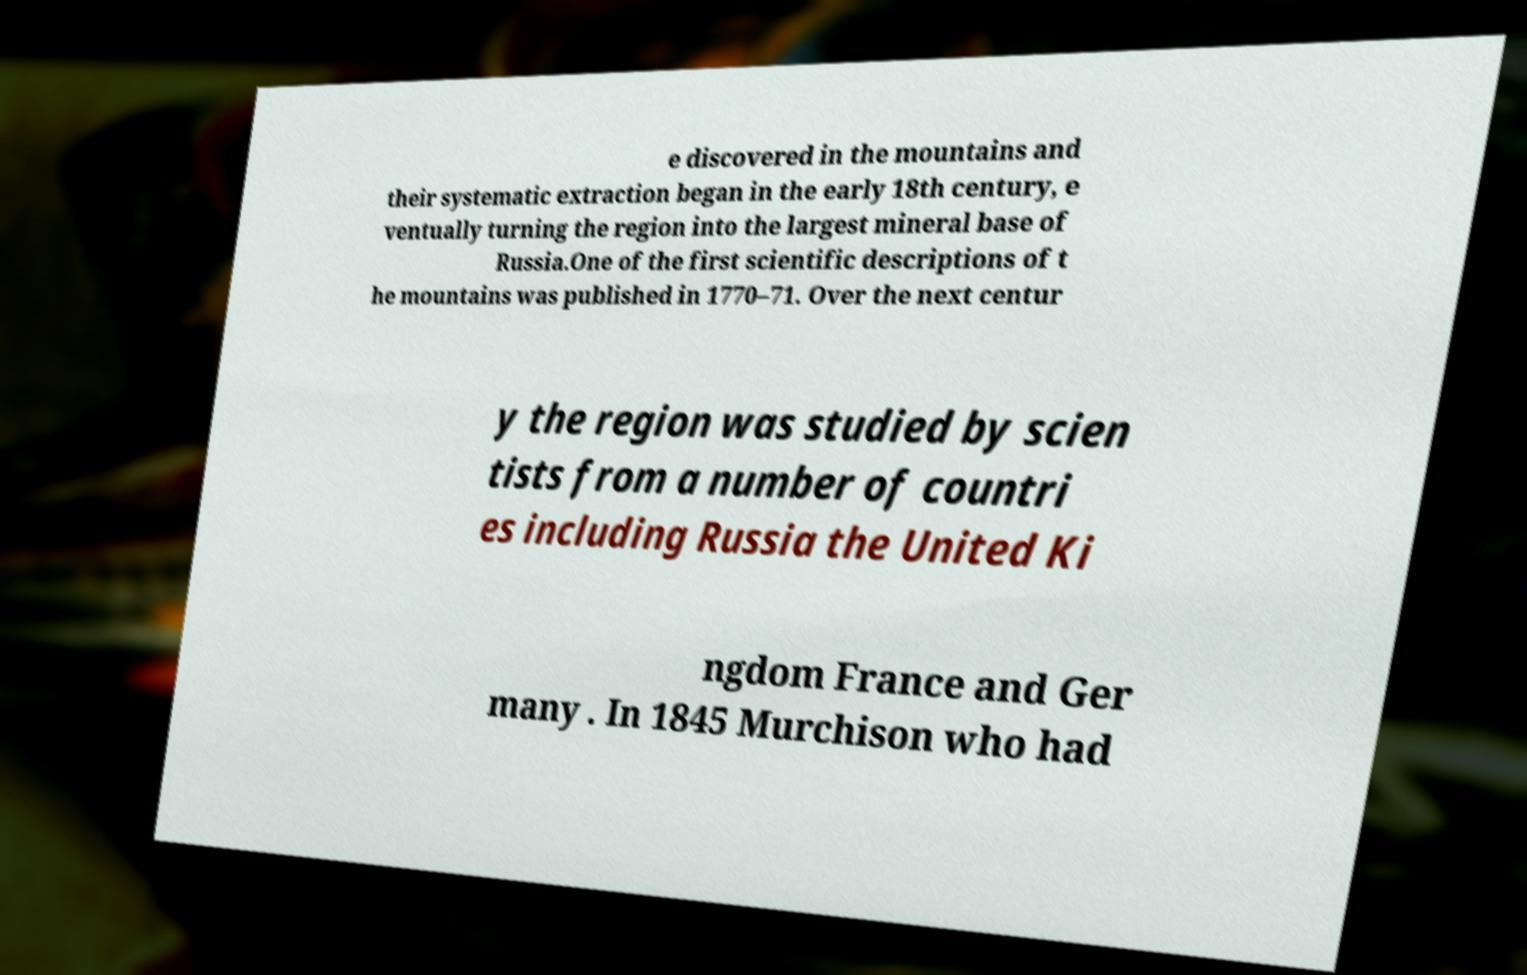I need the written content from this picture converted into text. Can you do that? e discovered in the mountains and their systematic extraction began in the early 18th century, e ventually turning the region into the largest mineral base of Russia.One of the first scientific descriptions of t he mountains was published in 1770–71. Over the next centur y the region was studied by scien tists from a number of countri es including Russia the United Ki ngdom France and Ger many . In 1845 Murchison who had 